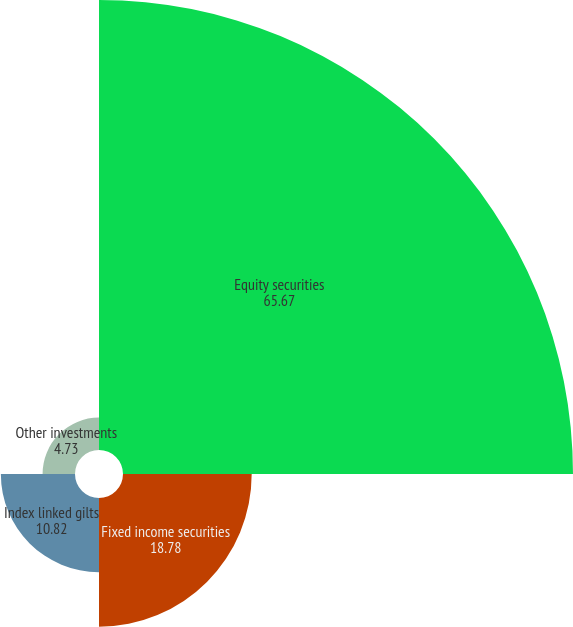Convert chart to OTSL. <chart><loc_0><loc_0><loc_500><loc_500><pie_chart><fcel>Equity securities<fcel>Fixed income securities<fcel>Index linked gilts<fcel>Other investments<nl><fcel>65.67%<fcel>18.78%<fcel>10.82%<fcel>4.73%<nl></chart> 